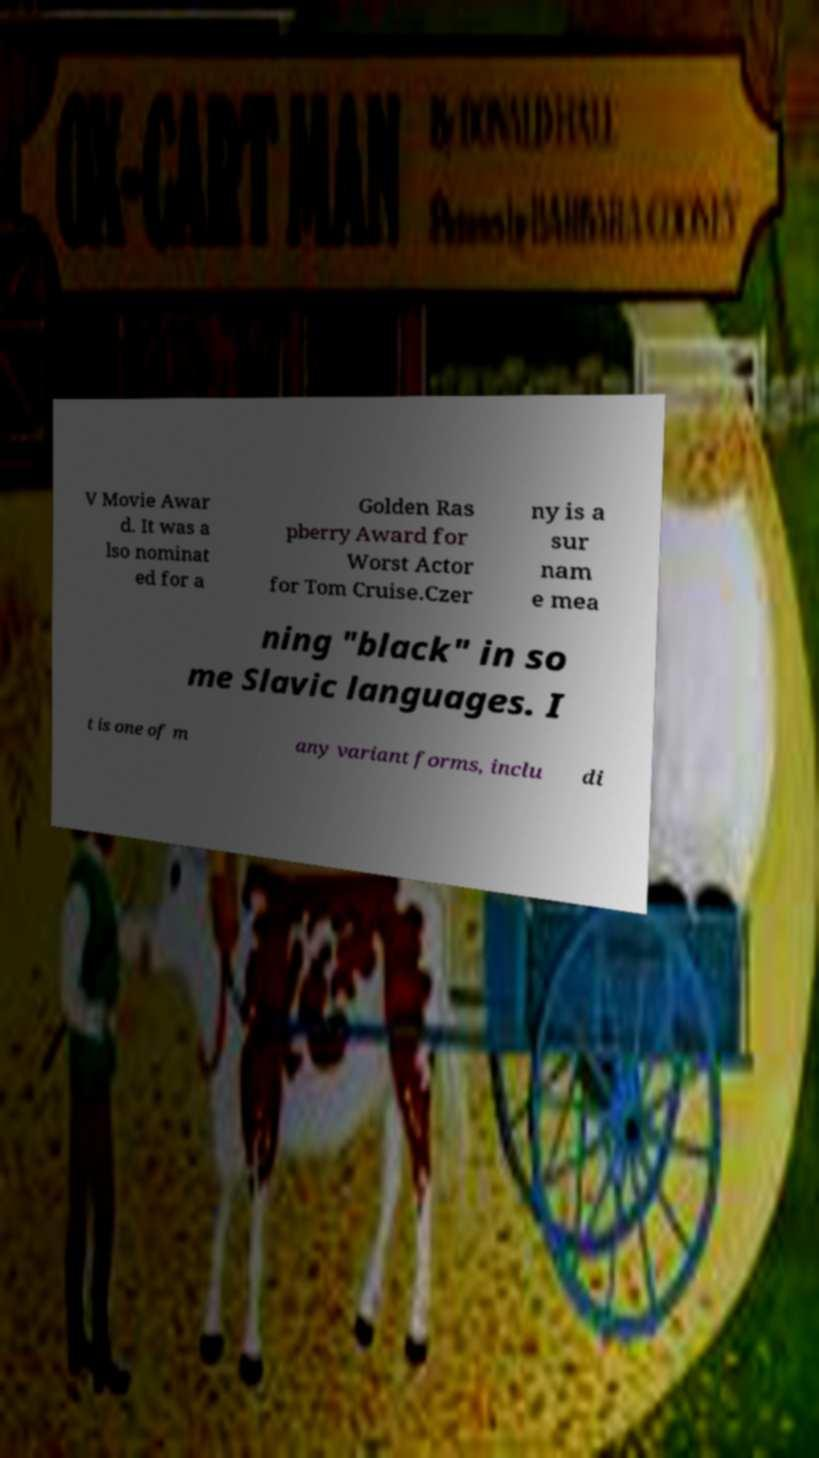Can you accurately transcribe the text from the provided image for me? V Movie Awar d. It was a lso nominat ed for a Golden Ras pberry Award for Worst Actor for Tom Cruise.Czer ny is a sur nam e mea ning "black" in so me Slavic languages. I t is one of m any variant forms, inclu di 